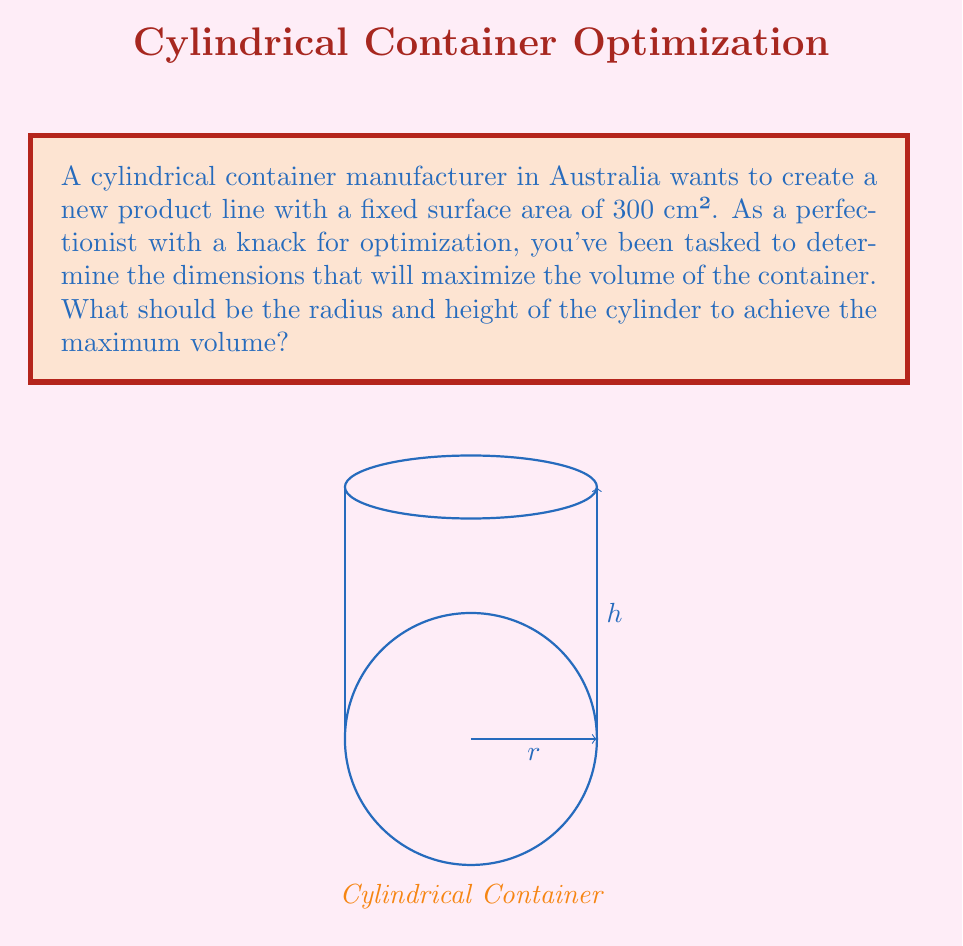Could you help me with this problem? Let's approach this step-by-step:

1) First, we need to express the surface area and volume of a cylinder in terms of its radius $r$ and height $h$:

   Surface Area: $A = 2\pi r^2 + 2\pi rh$
   Volume: $V = \pi r^2h$

2) We're given that the surface area is fixed at 300 cm². So:

   $300 = 2\pi r^2 + 2\pi rh$

3) Solve this equation for $h$:

   $h = \frac{300 - 2\pi r^2}{2\pi r}$

4) Now, substitute this expression for $h$ into the volume formula:

   $V = \pi r^2 (\frac{300 - 2\pi r^2}{2\pi r})$

5) Simplify:

   $V = 150r - \pi r^3$

6) To find the maximum volume, we need to find where $\frac{dV}{dr} = 0$:

   $\frac{dV}{dr} = 150 - 3\pi r^2$

7) Set this equal to zero and solve for $r$:

   $150 - 3\pi r^2 = 0$
   $3\pi r^2 = 150$
   $r^2 = \frac{50}{\pi}$
   $r = \sqrt{\frac{50}{\pi}} \approx 3.99$ cm

8) To find $h$, substitute this value of $r$ back into the equation from step 3:

   $h = \frac{300 - 2\pi (\frac{50}{\pi})}{2\pi \sqrt{\frac{50}{\pi}}} = \sqrt{\frac{50}{\pi}} \approx 3.99$ cm

9) Verify that this is indeed a maximum by checking the second derivative:

   $\frac{d^2V}{dr^2} = -6\pi r$

   This is negative when $r$ is positive, confirming a maximum.
Answer: $r = h = \sqrt{\frac{50}{\pi}} \approx 3.99$ cm 